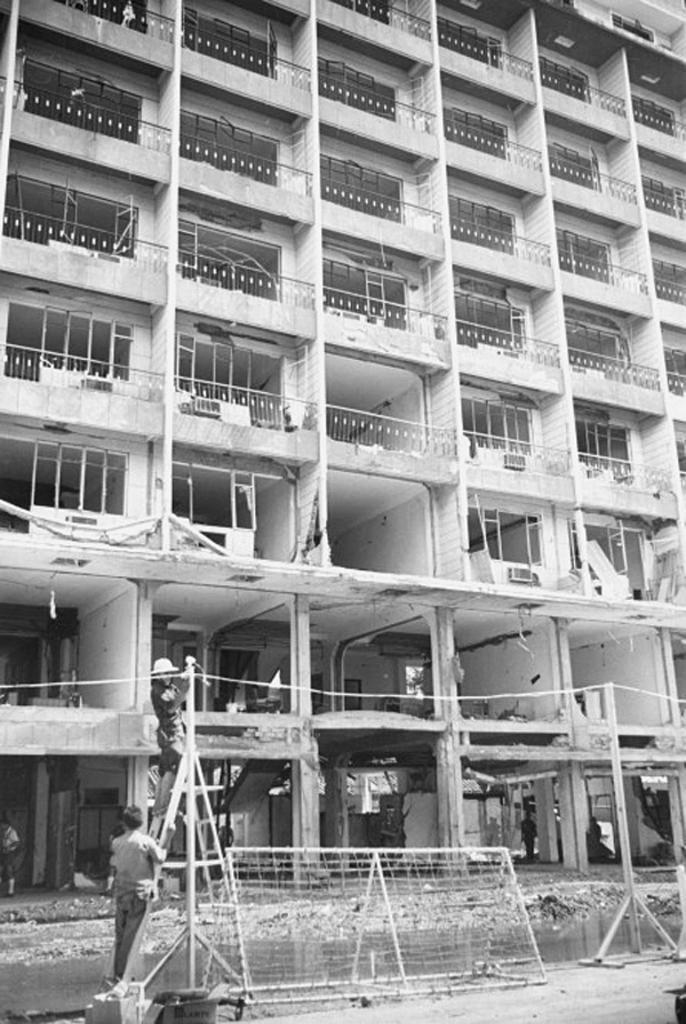What type of structure is visible in the image? There is a building in the image. What feature can be seen on the building? The building has windows. What object is present in the image that can be used for climbing or reaching higher places? There is a ladder in the image. What type of barrier is visible in the image? There is a fence in the image. What object is present in the image that can be used for displaying or holding items? There is a stand in the image. Are there any living beings visible in the image? Yes, there are people in the image. What type of flowers can be seen growing on the roof of the building in the image? There are no flowers visible on the roof of the building in the image. Can you hear a plane flying overhead in the image? There is no mention of a plane in the image, so it cannot be heard. Is there a drum being played by any of the people in the image? There is no mention of a drum or any musical instruments in the image. 